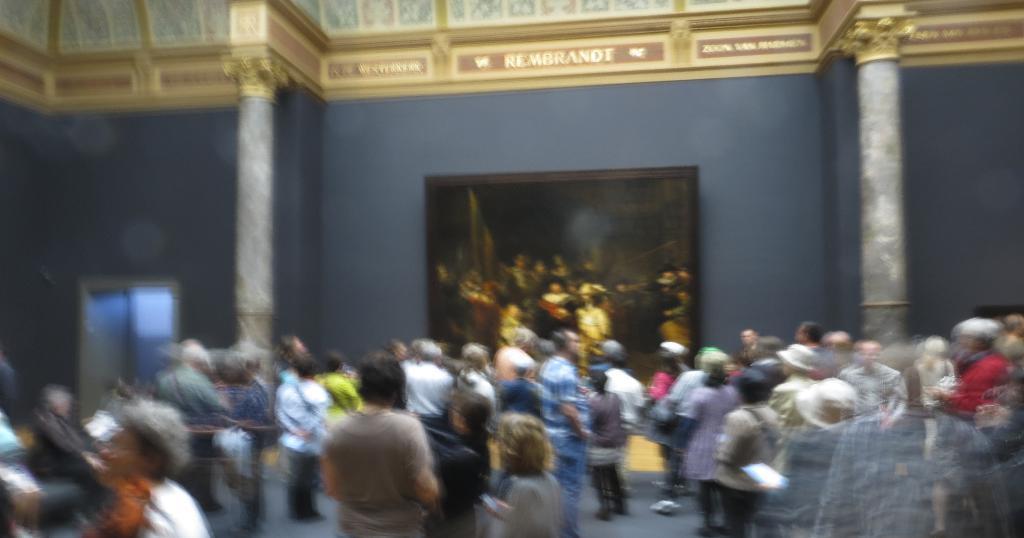In one or two sentences, can you explain what this image depicts? In the picture I can see few persons standing and there is a photo frame attached to the wall in the background. 